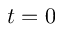<formula> <loc_0><loc_0><loc_500><loc_500>t = 0</formula> 